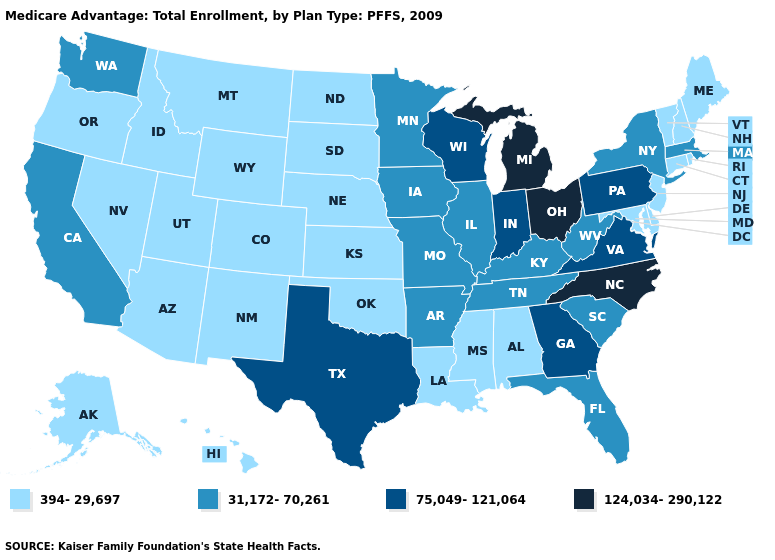Name the states that have a value in the range 394-29,697?
Quick response, please. Alaska, Alabama, Arizona, Colorado, Connecticut, Delaware, Hawaii, Idaho, Kansas, Louisiana, Maryland, Maine, Mississippi, Montana, North Dakota, Nebraska, New Hampshire, New Jersey, New Mexico, Nevada, Oklahoma, Oregon, Rhode Island, South Dakota, Utah, Vermont, Wyoming. How many symbols are there in the legend?
Write a very short answer. 4. What is the lowest value in the MidWest?
Short answer required. 394-29,697. Which states hav the highest value in the South?
Write a very short answer. North Carolina. What is the lowest value in the Northeast?
Short answer required. 394-29,697. What is the lowest value in the West?
Be succinct. 394-29,697. Name the states that have a value in the range 124,034-290,122?
Concise answer only. Michigan, North Carolina, Ohio. What is the value of North Dakota?
Be succinct. 394-29,697. Name the states that have a value in the range 124,034-290,122?
Be succinct. Michigan, North Carolina, Ohio. Does Alabama have the lowest value in the South?
Give a very brief answer. Yes. Name the states that have a value in the range 75,049-121,064?
Short answer required. Georgia, Indiana, Pennsylvania, Texas, Virginia, Wisconsin. What is the value of Rhode Island?
Concise answer only. 394-29,697. What is the value of North Dakota?
Quick response, please. 394-29,697. Among the states that border Wyoming , which have the lowest value?
Quick response, please. Colorado, Idaho, Montana, Nebraska, South Dakota, Utah. Name the states that have a value in the range 124,034-290,122?
Quick response, please. Michigan, North Carolina, Ohio. 